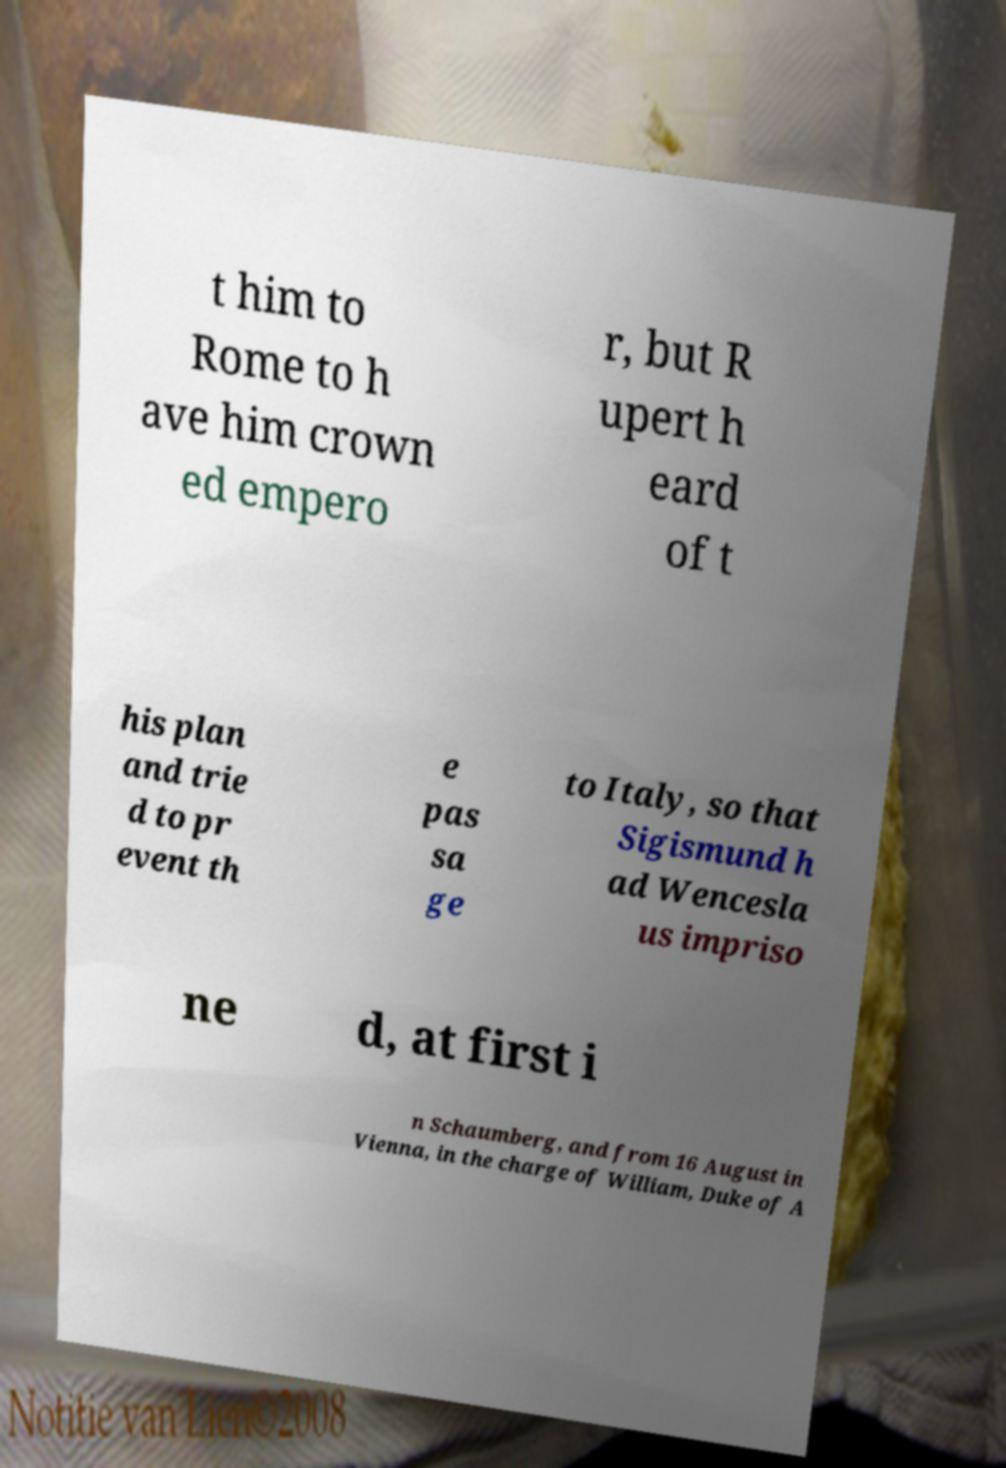Could you assist in decoding the text presented in this image and type it out clearly? t him to Rome to h ave him crown ed empero r, but R upert h eard of t his plan and trie d to pr event th e pas sa ge to Italy, so that Sigismund h ad Wencesla us impriso ne d, at first i n Schaumberg, and from 16 August in Vienna, in the charge of William, Duke of A 